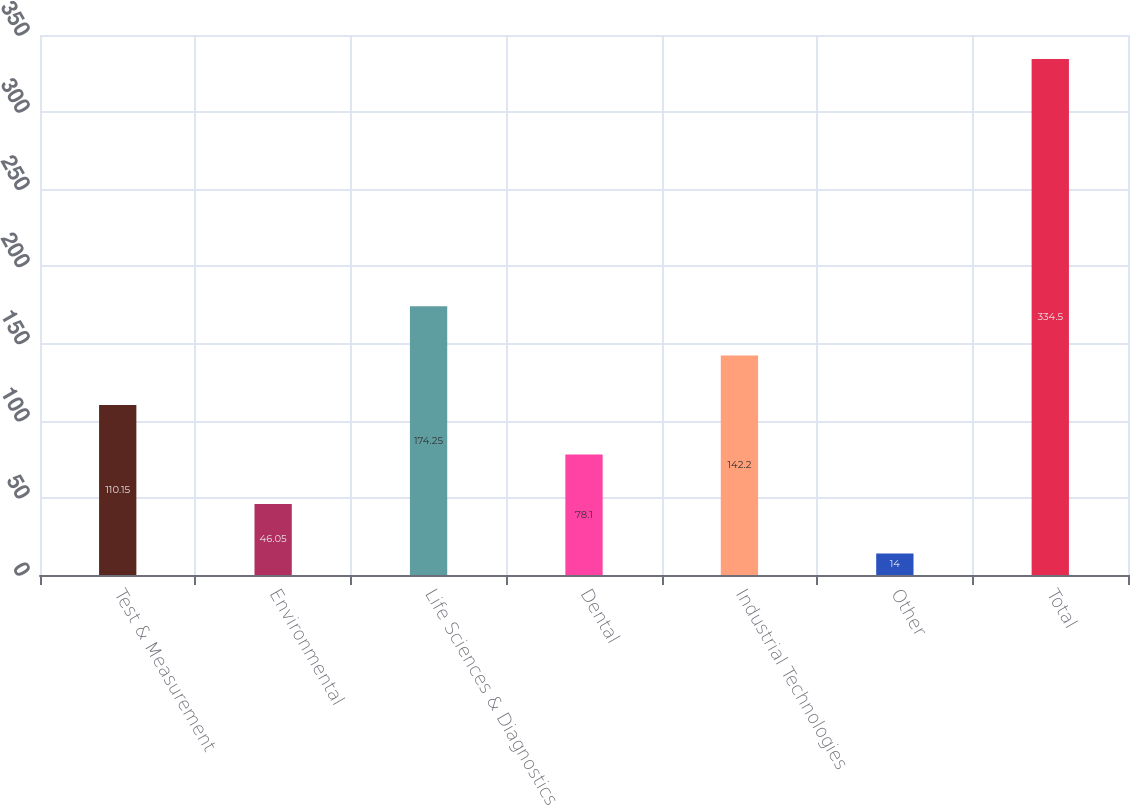Convert chart. <chart><loc_0><loc_0><loc_500><loc_500><bar_chart><fcel>Test & Measurement<fcel>Environmental<fcel>Life Sciences & Diagnostics<fcel>Dental<fcel>Industrial Technologies<fcel>Other<fcel>Total<nl><fcel>110.15<fcel>46.05<fcel>174.25<fcel>78.1<fcel>142.2<fcel>14<fcel>334.5<nl></chart> 